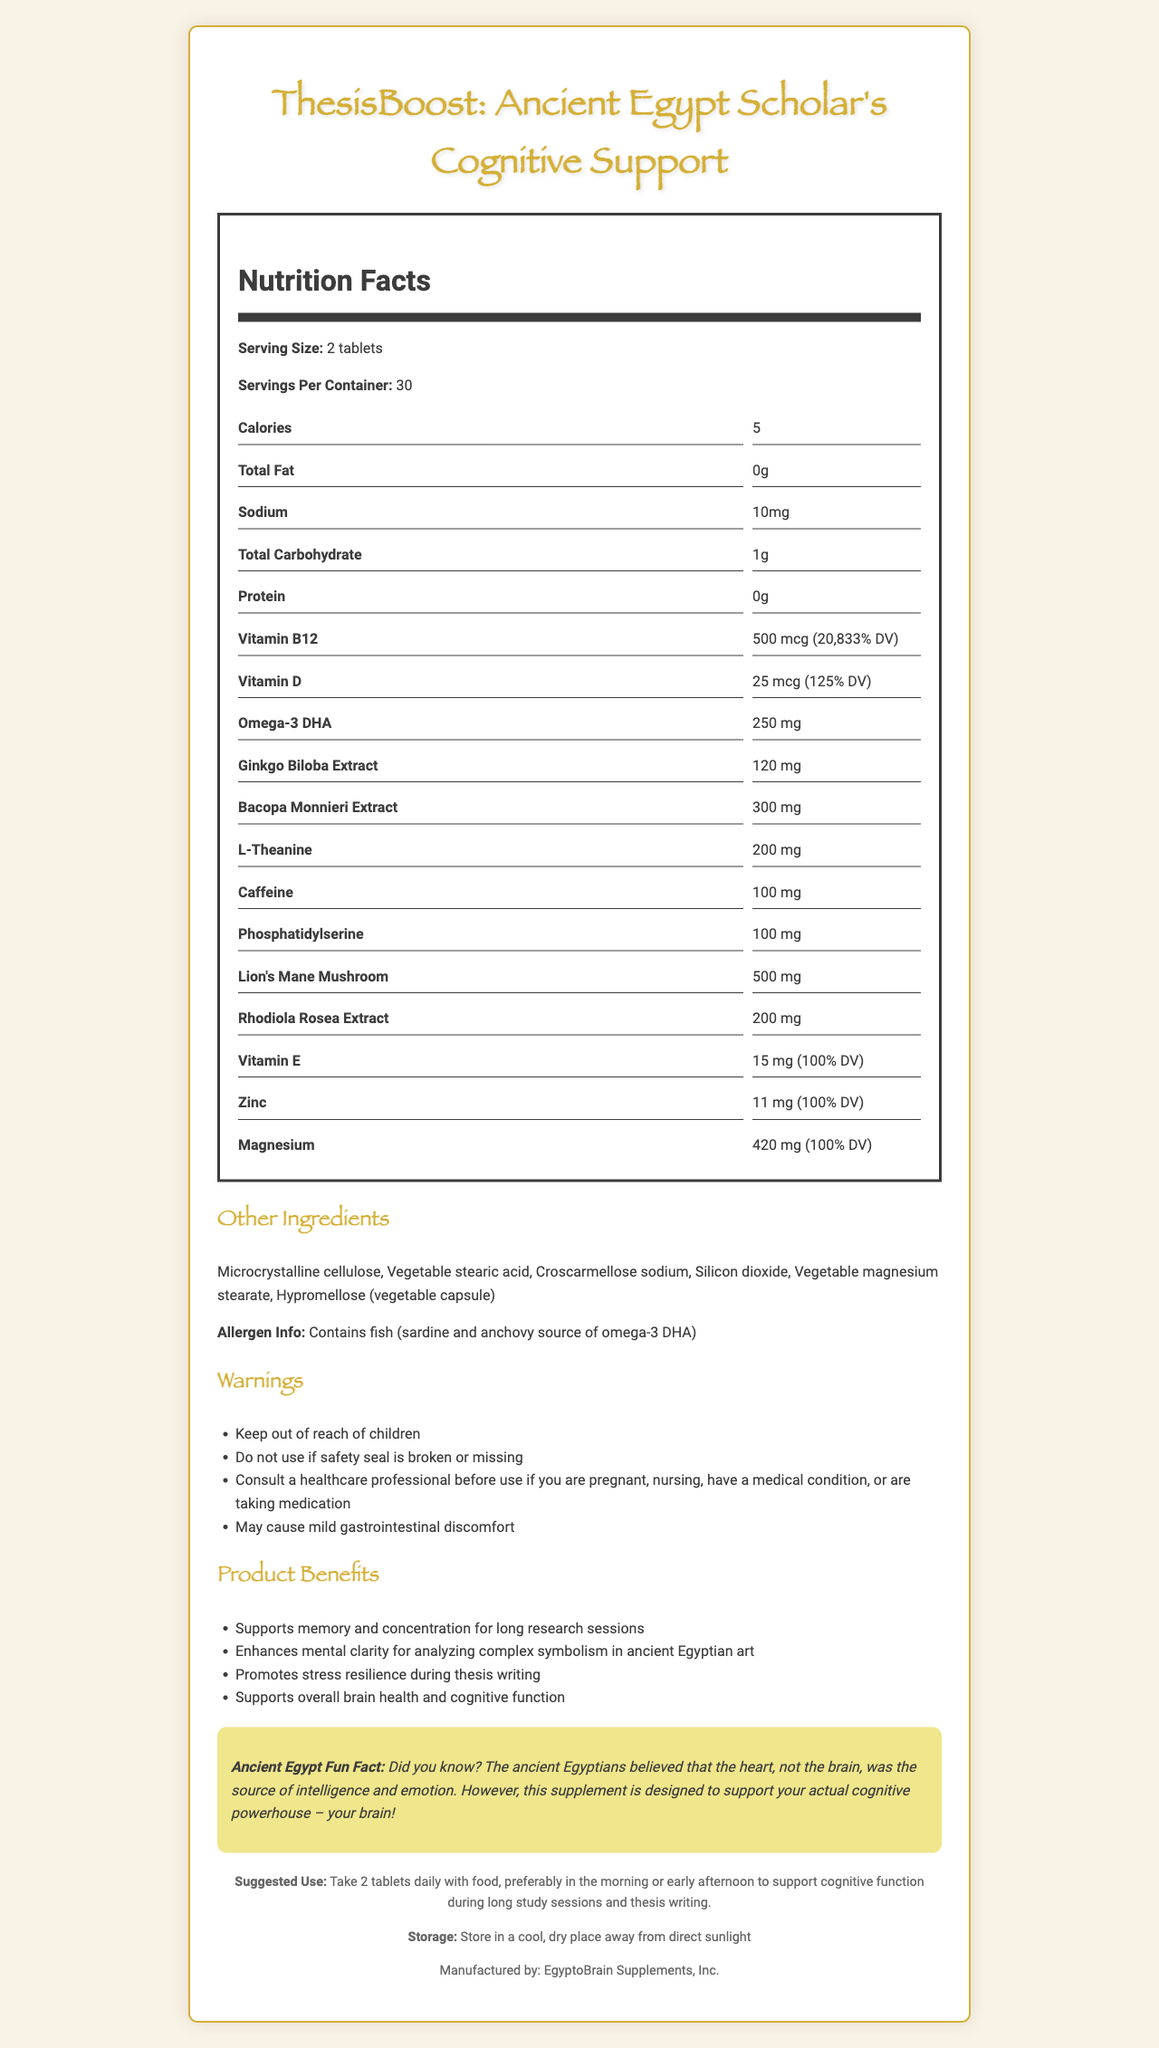what is the name of the product? The name of the product is clearly stated at the top of the document under the title section.
Answer: ThesisBoost: Ancient Egypt Scholar's Cognitive Support what is the suggested daily serving size for this vitamin supplement? The serving size for the supplement is indicated in the Nutrition Facts section as "2 tablets".
Answer: 2 tablets how many calories are in one serving of this supplement? The Nutrition Facts section lists the number of calories per serving as 5.
Answer: 5 calories what percent daily value of vitamin B12 does one serving provide? The Nutrition Facts section states that one serving provides 500 mcg of vitamin B12, which is 20,833% of the daily value.
Answer: 20,833% DV what warning is given regarding gastrointestinal discomfort? The warnings section includes the information that the supplement may cause mild gastrointestinal discomfort.
Answer: May cause mild gastrointestinal discomfort how many servings are in one container of this supplement? The Nutrition Facts section indicates that there are 30 servings per container.
Answer: 30 servings which ingredient in the supplement is sourced from fish? A. L-Theanine B. Omega-3 DHA C. Ginkgo Biloba Extract D. Phosphatidylserine The allergen information states that the Omega-3 DHA is sourced from sardine and anchovy fish.
Answer: B what are the recommended storage conditions for this supplement? A. Keep in a freezer B. Store in a cool, dry place away from direct sunlight C. Refrigerate after opening D. Store in a humid area The storage instructions recommend storing the product in a cool, dry place away from direct sunlight.
Answer: B does the supplement contain any protein? The Nutrition Facts section shows the protein content as 0 grams per serving.
Answer: No does the supplement support memory and concentration? The product benefits section lists "Supports memory and concentration for long research sessions" as a key benefit.
Answer: Yes summarize the document in one sentence The document includes various sections that comprehensively cover the supplement's nutritional content, benefits, suggested use, warnings, ingredient list, and storage instructions.
Answer: The document provides detailed nutritional information, benefits, usage instructions, and warnings for the ThesisBoost: Ancient Egypt Scholar's Cognitive Support supplement. what is the manufacture date of this supplement? The document does not include any information regarding the manufacture date of the supplement.
Answer: Not enough information what fun fact is included about ancient Egypt? The fun fact section provides this interesting piece of information about ancient Egyptian beliefs.
Answer: The ancient Egyptians believed that the heart, not the brain, was the source of intelligence and emotion. 